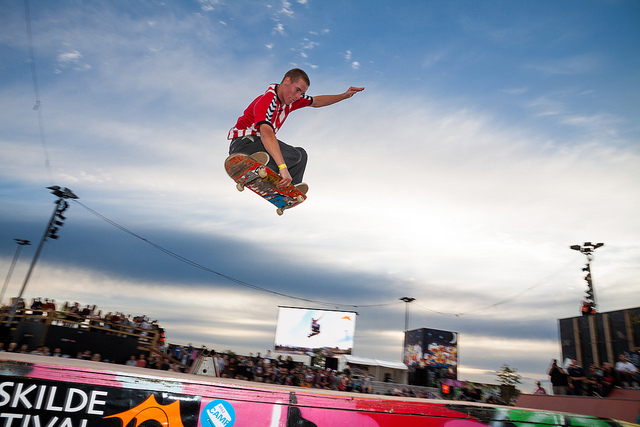What is the name of the trick the man in red is performing?
A. fakie
B. grind
C. manual
D. grab Based on the image, the trick the man in red is performing is a 'grab'. This involves grabbing the skateboard while in mid-air, adding style and control to the jump. 